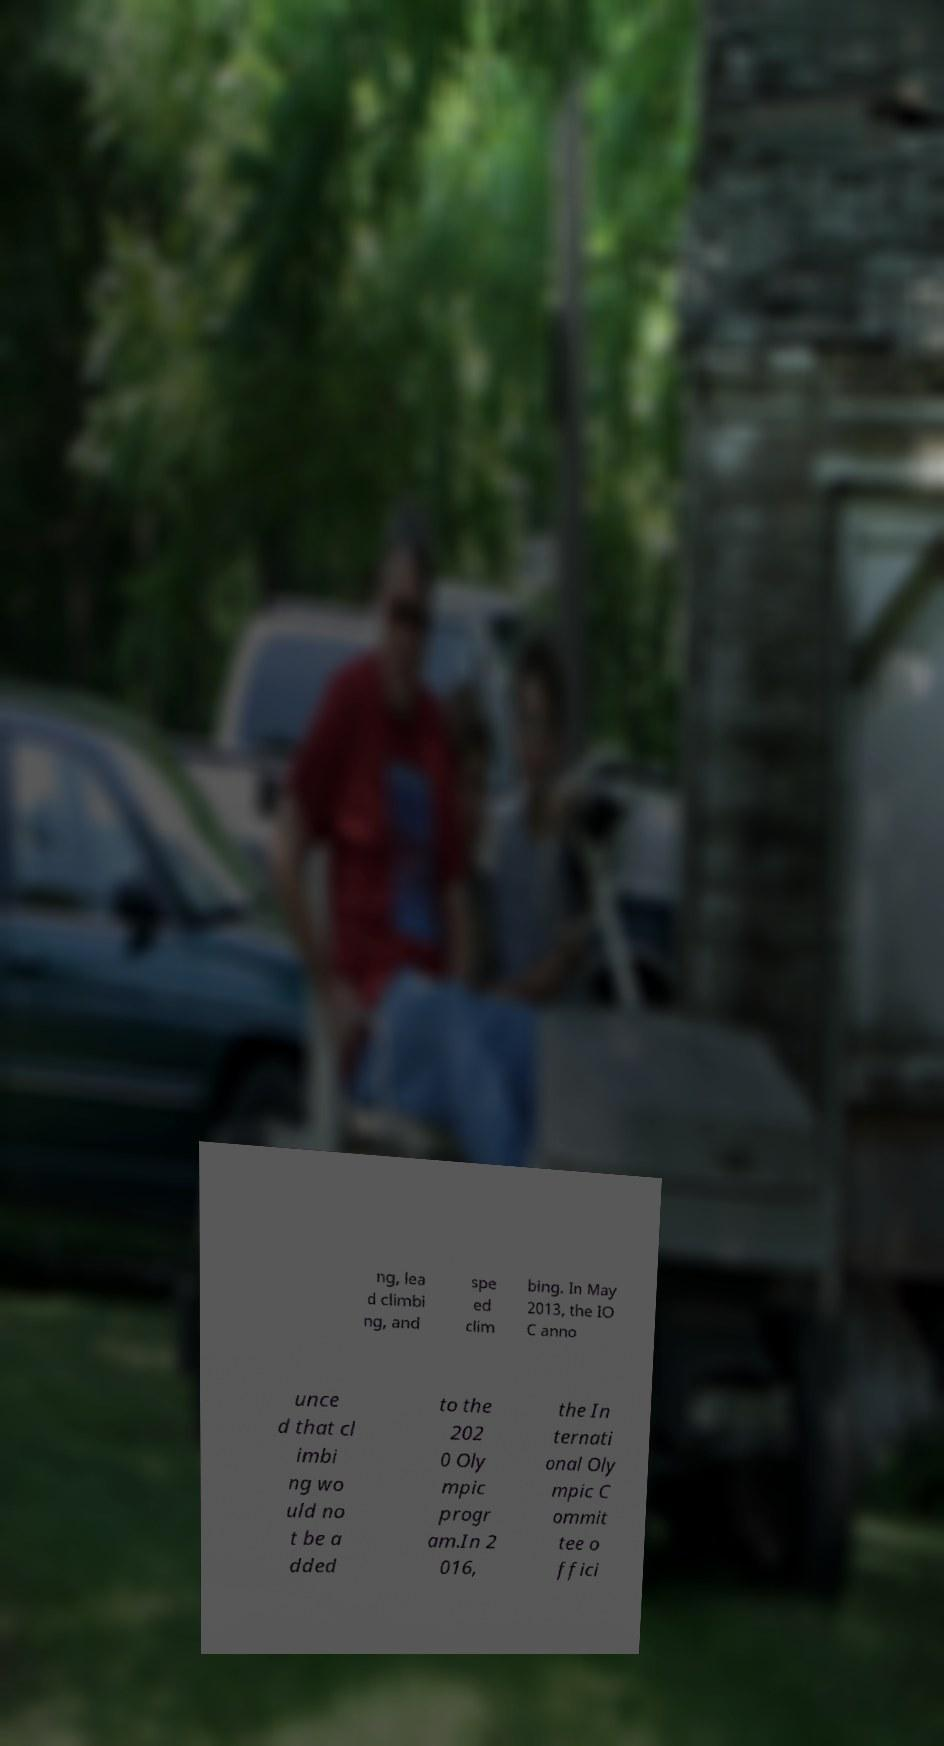I need the written content from this picture converted into text. Can you do that? ng, lea d climbi ng, and spe ed clim bing. In May 2013, the IO C anno unce d that cl imbi ng wo uld no t be a dded to the 202 0 Oly mpic progr am.In 2 016, the In ternati onal Oly mpic C ommit tee o ffici 